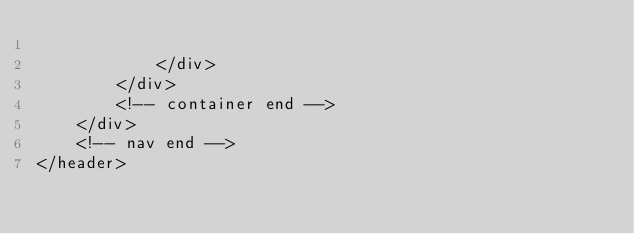<code> <loc_0><loc_0><loc_500><loc_500><_PHP_>
            </div>
        </div>
        <!-- container end -->
    </div>
    <!-- nav end -->
</header>
</code> 